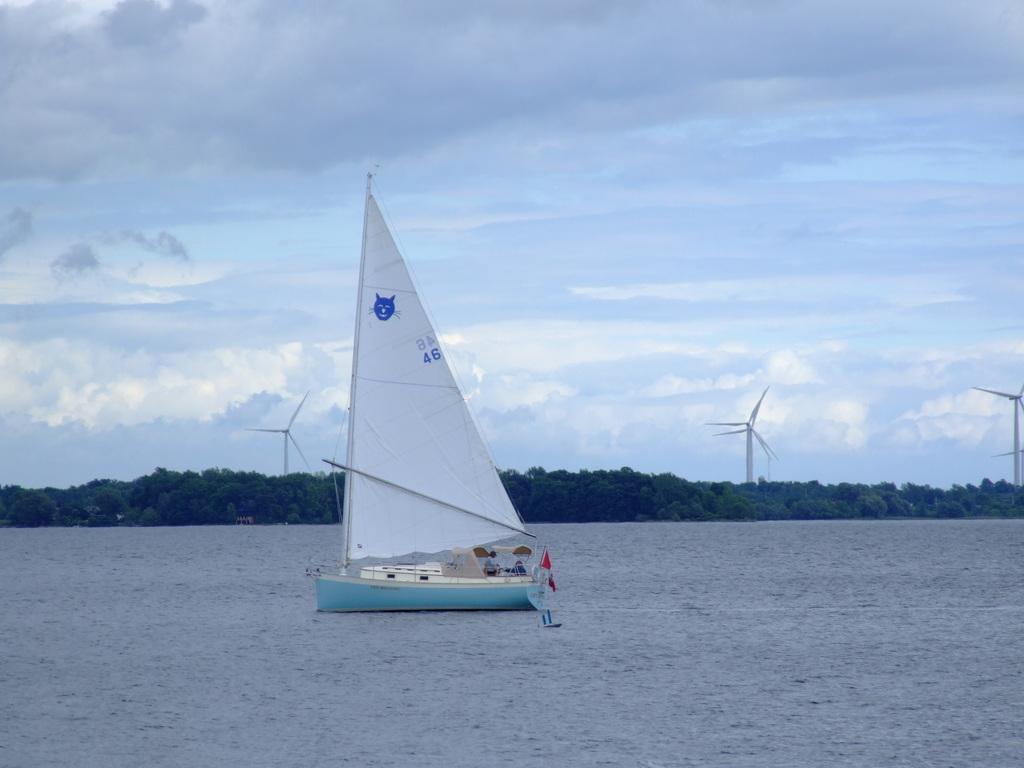Could you give a brief overview of what you see in this image? In the image there is a boat on the water surface, in the background there are trees. 